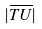Convert formula to latex. <formula><loc_0><loc_0><loc_500><loc_500>| \overline { T U } |</formula> 